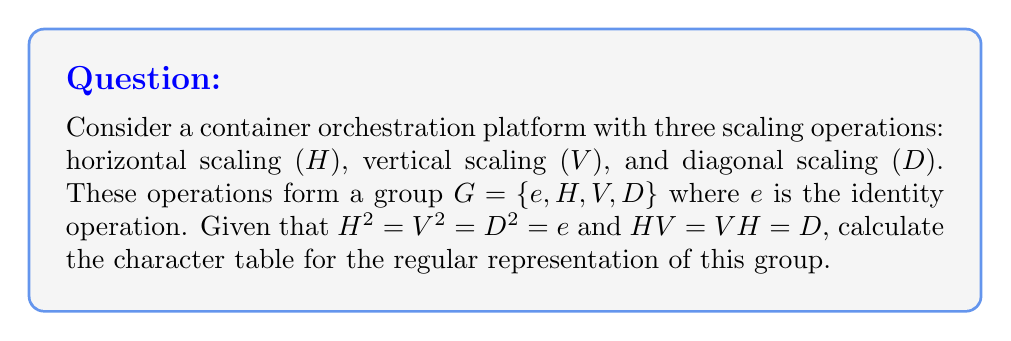Provide a solution to this math problem. 1. First, we need to identify the conjugacy classes of the group:
   - $\{e\}$
   - $\{H, V, D\}$

2. The number of irreducible representations is equal to the number of conjugacy classes, which is 2.

3. The dimensions of these representations must satisfy:
   $1^2 + 1^2 = 4$ (order of the group)
   So, we have two 1-dimensional representations.

4. Let's call these representations $\chi_1$ and $\chi_2$.

5. $\chi_1$ is always the trivial representation, assigning 1 to all elements.

6. For $\chi_2$, we know:
   - $\chi_2(e) = 1$ (as it's 1-dimensional)
   - $\chi_2(H)^2 = \chi_2(H^2) = \chi_2(e) = 1$, so $\chi_2(H) = \pm 1$
   - Similarly, $\chi_2(V) = \chi_2(D) = \pm 1$

7. To satisfy orthogonality with $\chi_1$, we must have:
   $1 + 3\chi_2(H) = 0$
   Therefore, $\chi_2(H) = \chi_2(V) = \chi_2(D) = -1$

8. The character table is thus:

   $$
   \begin{array}{c|cc}
    G & \{e\} & \{H,V,D\} \\
   \hline
   \chi_1 & 1 & 1 \\
   \chi_2 & 1 & -1
   \end{array}
   $$
Answer: $$
\begin{array}{c|cc}
 G & \{e\} & \{H,V,D\} \\
\hline
\chi_1 & 1 & 1 \\
\chi_2 & 1 & -1
\end{array}
$$ 